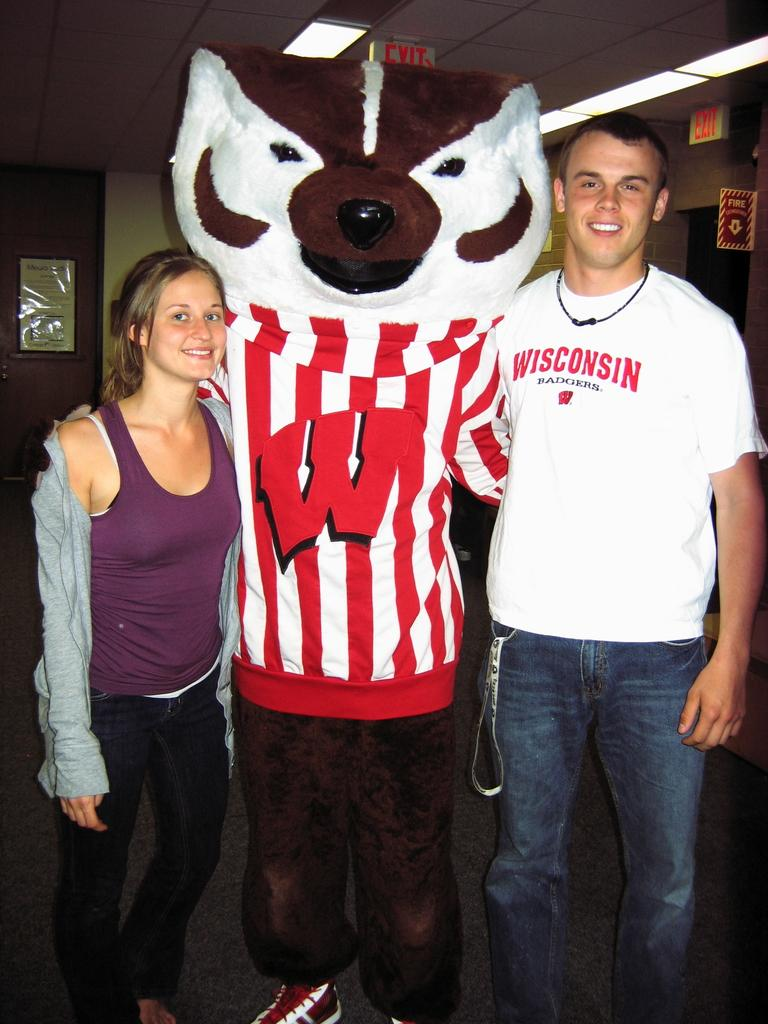Provide a one-sentence caption for the provided image. Two people stand with a mascot with a big red W on it. 